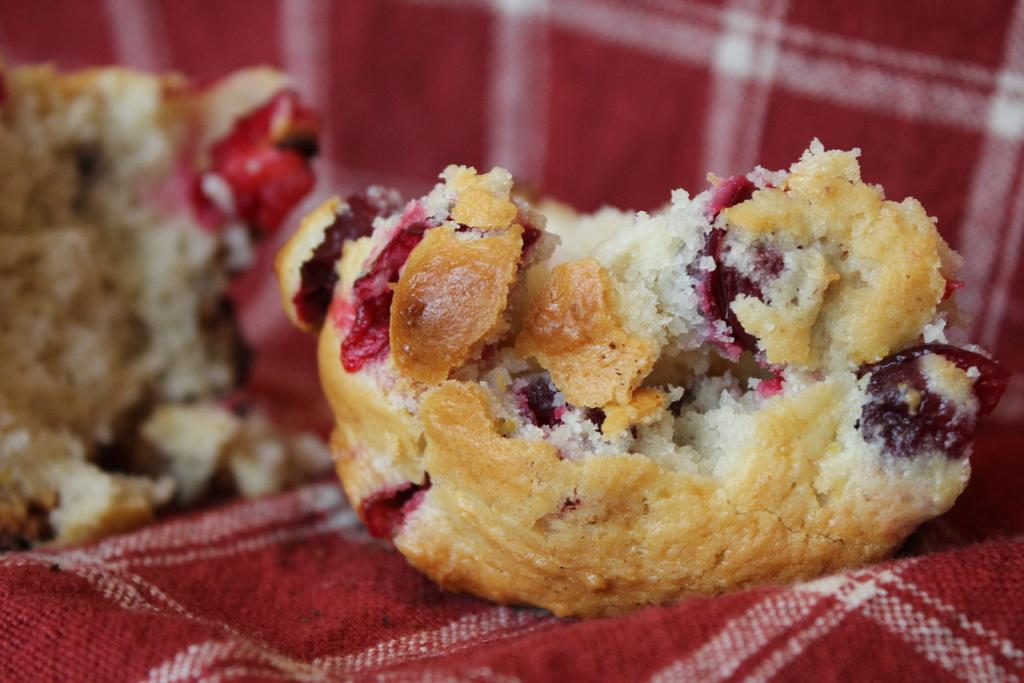What can be seen in the image? There are food items in the image. How are the food items arranged or presented? The food items are placed on a cloth. Is there a woman in the garden tending to the food items in the image? There is no woman or garden present in the image; it only features food items placed on a cloth. 